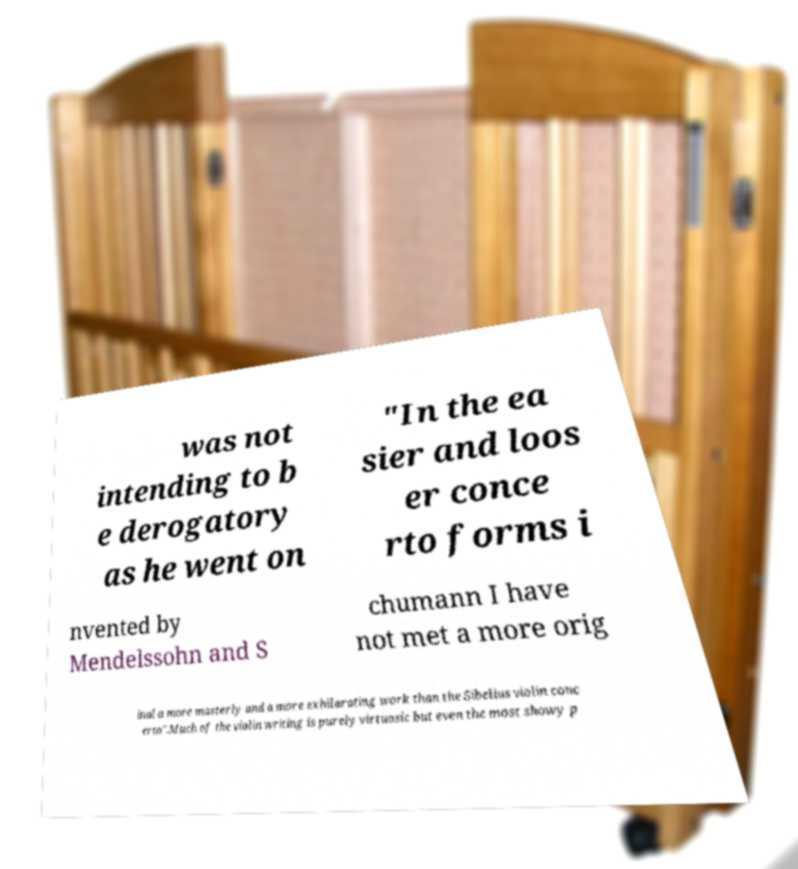Can you accurately transcribe the text from the provided image for me? was not intending to b e derogatory as he went on "In the ea sier and loos er conce rto forms i nvented by Mendelssohn and S chumann I have not met a more orig inal a more masterly and a more exhilarating work than the Sibelius violin conc erto".Much of the violin writing is purely virtuosic but even the most showy p 